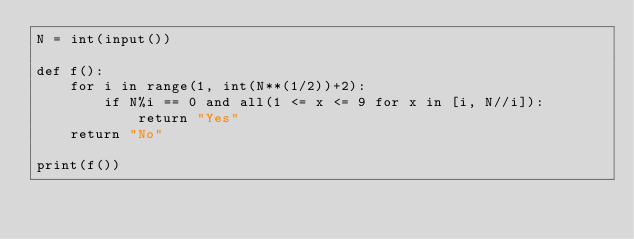Convert code to text. <code><loc_0><loc_0><loc_500><loc_500><_Python_>N = int(input())

def f():
    for i in range(1, int(N**(1/2))+2):
        if N%i == 0 and all(1 <= x <= 9 for x in [i, N//i]):
            return "Yes"
    return "No"

print(f())</code> 